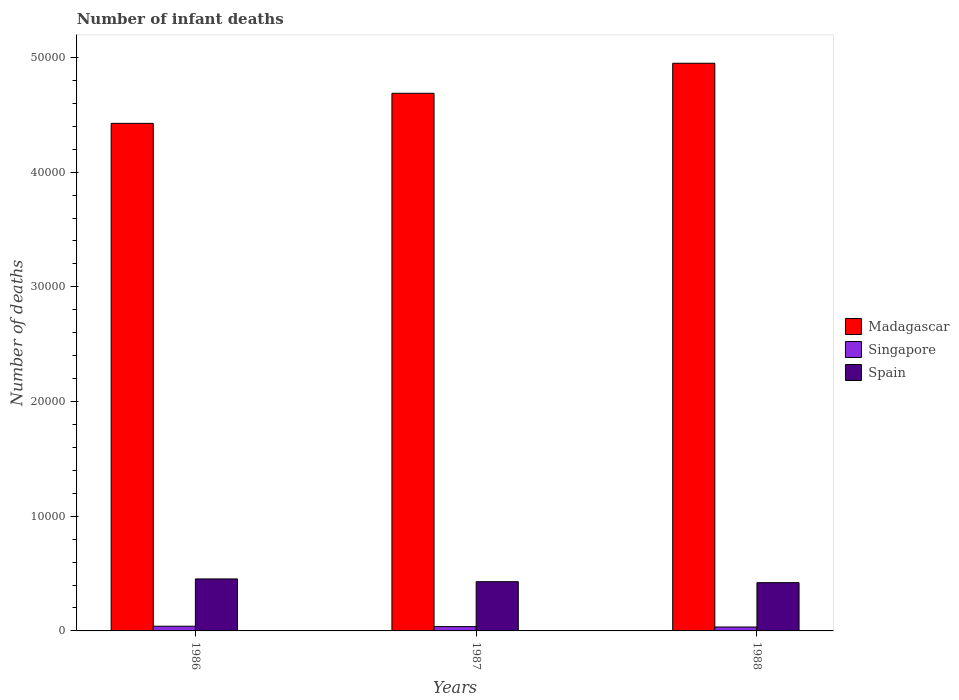Are the number of bars per tick equal to the number of legend labels?
Provide a succinct answer. Yes. What is the label of the 1st group of bars from the left?
Your response must be concise. 1986. In how many cases, is the number of bars for a given year not equal to the number of legend labels?
Your answer should be compact. 0. What is the number of infant deaths in Madagascar in 1988?
Offer a terse response. 4.95e+04. Across all years, what is the maximum number of infant deaths in Singapore?
Provide a succinct answer. 409. Across all years, what is the minimum number of infant deaths in Spain?
Keep it short and to the point. 4207. In which year was the number of infant deaths in Madagascar maximum?
Keep it short and to the point. 1988. What is the total number of infant deaths in Madagascar in the graph?
Make the answer very short. 1.41e+05. What is the difference between the number of infant deaths in Spain in 1986 and that in 1988?
Your answer should be compact. 326. What is the difference between the number of infant deaths in Spain in 1986 and the number of infant deaths in Madagascar in 1987?
Make the answer very short. -4.23e+04. What is the average number of infant deaths in Spain per year?
Your answer should be compact. 4344. In the year 1987, what is the difference between the number of infant deaths in Spain and number of infant deaths in Singapore?
Offer a terse response. 3916. What is the ratio of the number of infant deaths in Spain in 1987 to that in 1988?
Provide a succinct answer. 1.02. What is the difference between the highest and the second highest number of infant deaths in Singapore?
Provide a short and direct response. 33. What is the difference between the highest and the lowest number of infant deaths in Spain?
Give a very brief answer. 326. In how many years, is the number of infant deaths in Singapore greater than the average number of infant deaths in Singapore taken over all years?
Your response must be concise. 2. What does the 3rd bar from the left in 1988 represents?
Keep it short and to the point. Spain. What does the 2nd bar from the right in 1986 represents?
Your response must be concise. Singapore. Is it the case that in every year, the sum of the number of infant deaths in Spain and number of infant deaths in Singapore is greater than the number of infant deaths in Madagascar?
Ensure brevity in your answer.  No. How many bars are there?
Ensure brevity in your answer.  9. Are all the bars in the graph horizontal?
Provide a succinct answer. No. What is the difference between two consecutive major ticks on the Y-axis?
Your response must be concise. 10000. Does the graph contain any zero values?
Offer a very short reply. No. Does the graph contain grids?
Your answer should be very brief. No. How are the legend labels stacked?
Keep it short and to the point. Vertical. What is the title of the graph?
Keep it short and to the point. Number of infant deaths. What is the label or title of the X-axis?
Your response must be concise. Years. What is the label or title of the Y-axis?
Make the answer very short. Number of deaths. What is the Number of deaths in Madagascar in 1986?
Your answer should be compact. 4.43e+04. What is the Number of deaths in Singapore in 1986?
Provide a succinct answer. 409. What is the Number of deaths of Spain in 1986?
Provide a succinct answer. 4533. What is the Number of deaths of Madagascar in 1987?
Give a very brief answer. 4.69e+04. What is the Number of deaths in Singapore in 1987?
Make the answer very short. 376. What is the Number of deaths in Spain in 1987?
Keep it short and to the point. 4292. What is the Number of deaths in Madagascar in 1988?
Provide a short and direct response. 4.95e+04. What is the Number of deaths in Singapore in 1988?
Your answer should be very brief. 341. What is the Number of deaths in Spain in 1988?
Keep it short and to the point. 4207. Across all years, what is the maximum Number of deaths in Madagascar?
Keep it short and to the point. 4.95e+04. Across all years, what is the maximum Number of deaths of Singapore?
Make the answer very short. 409. Across all years, what is the maximum Number of deaths of Spain?
Offer a terse response. 4533. Across all years, what is the minimum Number of deaths of Madagascar?
Your answer should be very brief. 4.43e+04. Across all years, what is the minimum Number of deaths of Singapore?
Your answer should be very brief. 341. Across all years, what is the minimum Number of deaths in Spain?
Your response must be concise. 4207. What is the total Number of deaths of Madagascar in the graph?
Offer a terse response. 1.41e+05. What is the total Number of deaths in Singapore in the graph?
Offer a very short reply. 1126. What is the total Number of deaths of Spain in the graph?
Give a very brief answer. 1.30e+04. What is the difference between the Number of deaths of Madagascar in 1986 and that in 1987?
Keep it short and to the point. -2622. What is the difference between the Number of deaths in Spain in 1986 and that in 1987?
Your answer should be very brief. 241. What is the difference between the Number of deaths in Madagascar in 1986 and that in 1988?
Ensure brevity in your answer.  -5240. What is the difference between the Number of deaths of Singapore in 1986 and that in 1988?
Make the answer very short. 68. What is the difference between the Number of deaths of Spain in 1986 and that in 1988?
Make the answer very short. 326. What is the difference between the Number of deaths in Madagascar in 1987 and that in 1988?
Keep it short and to the point. -2618. What is the difference between the Number of deaths of Singapore in 1987 and that in 1988?
Your response must be concise. 35. What is the difference between the Number of deaths in Spain in 1987 and that in 1988?
Offer a very short reply. 85. What is the difference between the Number of deaths in Madagascar in 1986 and the Number of deaths in Singapore in 1987?
Ensure brevity in your answer.  4.39e+04. What is the difference between the Number of deaths in Madagascar in 1986 and the Number of deaths in Spain in 1987?
Make the answer very short. 4.00e+04. What is the difference between the Number of deaths of Singapore in 1986 and the Number of deaths of Spain in 1987?
Your answer should be compact. -3883. What is the difference between the Number of deaths of Madagascar in 1986 and the Number of deaths of Singapore in 1988?
Your response must be concise. 4.39e+04. What is the difference between the Number of deaths of Madagascar in 1986 and the Number of deaths of Spain in 1988?
Your answer should be compact. 4.00e+04. What is the difference between the Number of deaths of Singapore in 1986 and the Number of deaths of Spain in 1988?
Your answer should be compact. -3798. What is the difference between the Number of deaths of Madagascar in 1987 and the Number of deaths of Singapore in 1988?
Make the answer very short. 4.65e+04. What is the difference between the Number of deaths in Madagascar in 1987 and the Number of deaths in Spain in 1988?
Offer a very short reply. 4.27e+04. What is the difference between the Number of deaths in Singapore in 1987 and the Number of deaths in Spain in 1988?
Your response must be concise. -3831. What is the average Number of deaths of Madagascar per year?
Offer a terse response. 4.69e+04. What is the average Number of deaths in Singapore per year?
Provide a succinct answer. 375.33. What is the average Number of deaths in Spain per year?
Make the answer very short. 4344. In the year 1986, what is the difference between the Number of deaths of Madagascar and Number of deaths of Singapore?
Your answer should be very brief. 4.38e+04. In the year 1986, what is the difference between the Number of deaths in Madagascar and Number of deaths in Spain?
Your response must be concise. 3.97e+04. In the year 1986, what is the difference between the Number of deaths of Singapore and Number of deaths of Spain?
Your answer should be very brief. -4124. In the year 1987, what is the difference between the Number of deaths in Madagascar and Number of deaths in Singapore?
Your answer should be compact. 4.65e+04. In the year 1987, what is the difference between the Number of deaths in Madagascar and Number of deaths in Spain?
Ensure brevity in your answer.  4.26e+04. In the year 1987, what is the difference between the Number of deaths in Singapore and Number of deaths in Spain?
Your answer should be very brief. -3916. In the year 1988, what is the difference between the Number of deaths of Madagascar and Number of deaths of Singapore?
Your answer should be compact. 4.92e+04. In the year 1988, what is the difference between the Number of deaths in Madagascar and Number of deaths in Spain?
Ensure brevity in your answer.  4.53e+04. In the year 1988, what is the difference between the Number of deaths of Singapore and Number of deaths of Spain?
Your answer should be very brief. -3866. What is the ratio of the Number of deaths of Madagascar in 1986 to that in 1987?
Ensure brevity in your answer.  0.94. What is the ratio of the Number of deaths in Singapore in 1986 to that in 1987?
Make the answer very short. 1.09. What is the ratio of the Number of deaths of Spain in 1986 to that in 1987?
Give a very brief answer. 1.06. What is the ratio of the Number of deaths in Madagascar in 1986 to that in 1988?
Provide a short and direct response. 0.89. What is the ratio of the Number of deaths of Singapore in 1986 to that in 1988?
Keep it short and to the point. 1.2. What is the ratio of the Number of deaths in Spain in 1986 to that in 1988?
Offer a very short reply. 1.08. What is the ratio of the Number of deaths of Madagascar in 1987 to that in 1988?
Offer a terse response. 0.95. What is the ratio of the Number of deaths of Singapore in 1987 to that in 1988?
Ensure brevity in your answer.  1.1. What is the ratio of the Number of deaths in Spain in 1987 to that in 1988?
Make the answer very short. 1.02. What is the difference between the highest and the second highest Number of deaths in Madagascar?
Your answer should be very brief. 2618. What is the difference between the highest and the second highest Number of deaths of Singapore?
Your answer should be very brief. 33. What is the difference between the highest and the second highest Number of deaths of Spain?
Provide a short and direct response. 241. What is the difference between the highest and the lowest Number of deaths in Madagascar?
Your response must be concise. 5240. What is the difference between the highest and the lowest Number of deaths of Spain?
Provide a short and direct response. 326. 